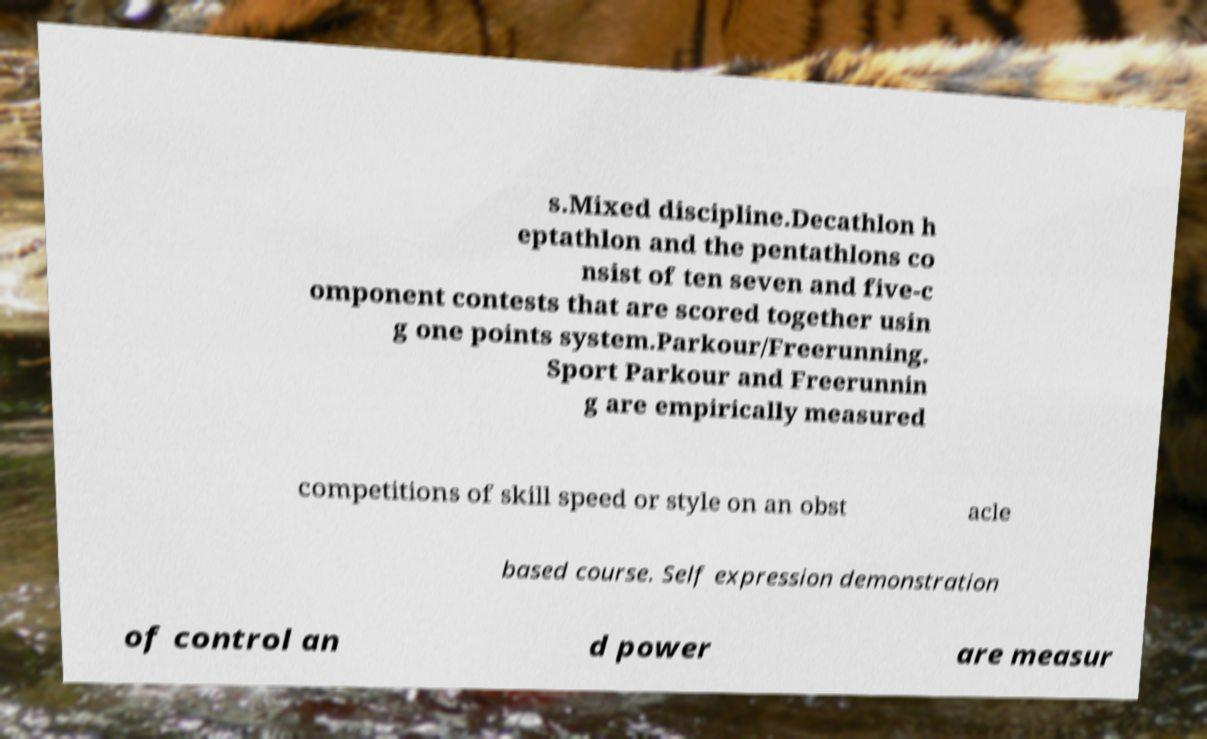Please identify and transcribe the text found in this image. s.Mixed discipline.Decathlon h eptathlon and the pentathlons co nsist of ten seven and five-c omponent contests that are scored together usin g one points system.Parkour/Freerunning. Sport Parkour and Freerunnin g are empirically measured competitions of skill speed or style on an obst acle based course. Self expression demonstration of control an d power are measur 